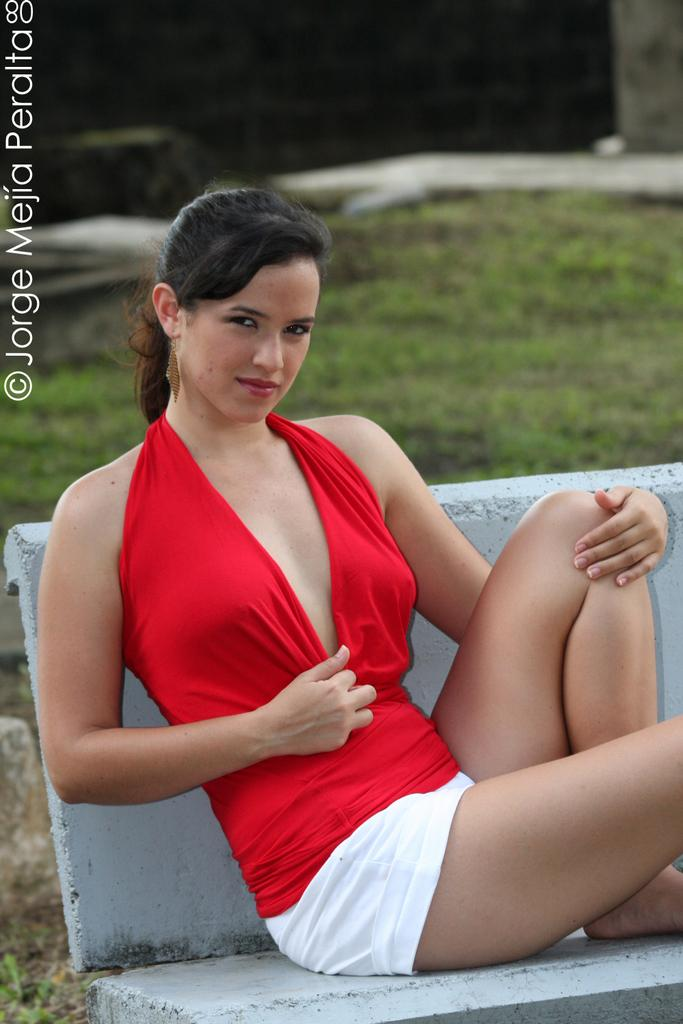Who is in the image? There is a woman in the image. What is the woman doing in the image? The woman is sitting on a bench and posing for a photo. Is there any text in the image? Yes, there is some text at the top left corner of the image. Can you see any kites flying in the image? There is no kite present in the image. What is the color of the sea in the image? There is no sea present in the image. 